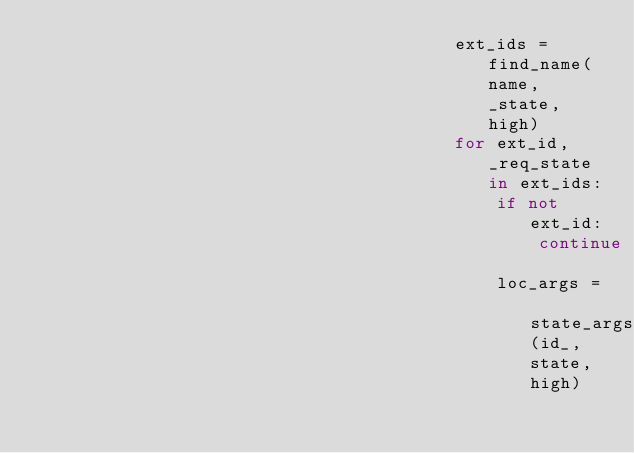Convert code to text. <code><loc_0><loc_0><loc_500><loc_500><_Python_>                                        ext_ids = find_name(name, _state, high)
                                        for ext_id, _req_state in ext_ids:
                                            if not ext_id:
                                                continue
                                            loc_args = state_args(id_, state, high)</code> 